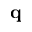Convert formula to latex. <formula><loc_0><loc_0><loc_500><loc_500>q</formula> 